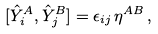Convert formula to latex. <formula><loc_0><loc_0><loc_500><loc_500>[ \hat { Y } ^ { A } _ { i } , \hat { Y } ^ { B } _ { j } ] = \epsilon _ { i j } \, \eta ^ { A B } \, ,</formula> 